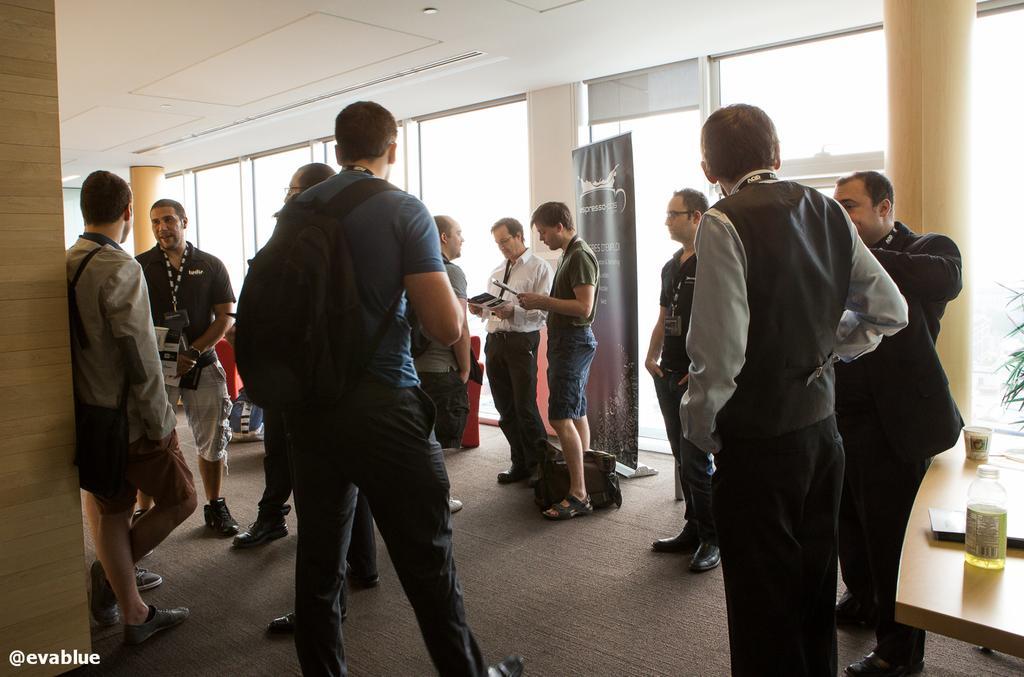Describe this image in one or two sentences. In the image in the center we can see few people were standing,few people were holding some objects and few people were wearing backpacks. On the left bottom of the image,there is a water mark. And on the right side of the image,there is a table. On the table,we can see bottle,book and glass. In the background there is a wall,roof,glass,banner,plant,backpacks and pillars. 